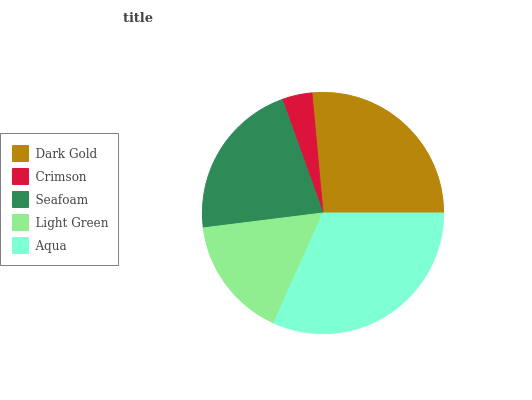Is Crimson the minimum?
Answer yes or no. Yes. Is Aqua the maximum?
Answer yes or no. Yes. Is Seafoam the minimum?
Answer yes or no. No. Is Seafoam the maximum?
Answer yes or no. No. Is Seafoam greater than Crimson?
Answer yes or no. Yes. Is Crimson less than Seafoam?
Answer yes or no. Yes. Is Crimson greater than Seafoam?
Answer yes or no. No. Is Seafoam less than Crimson?
Answer yes or no. No. Is Seafoam the high median?
Answer yes or no. Yes. Is Seafoam the low median?
Answer yes or no. Yes. Is Light Green the high median?
Answer yes or no. No. Is Aqua the low median?
Answer yes or no. No. 